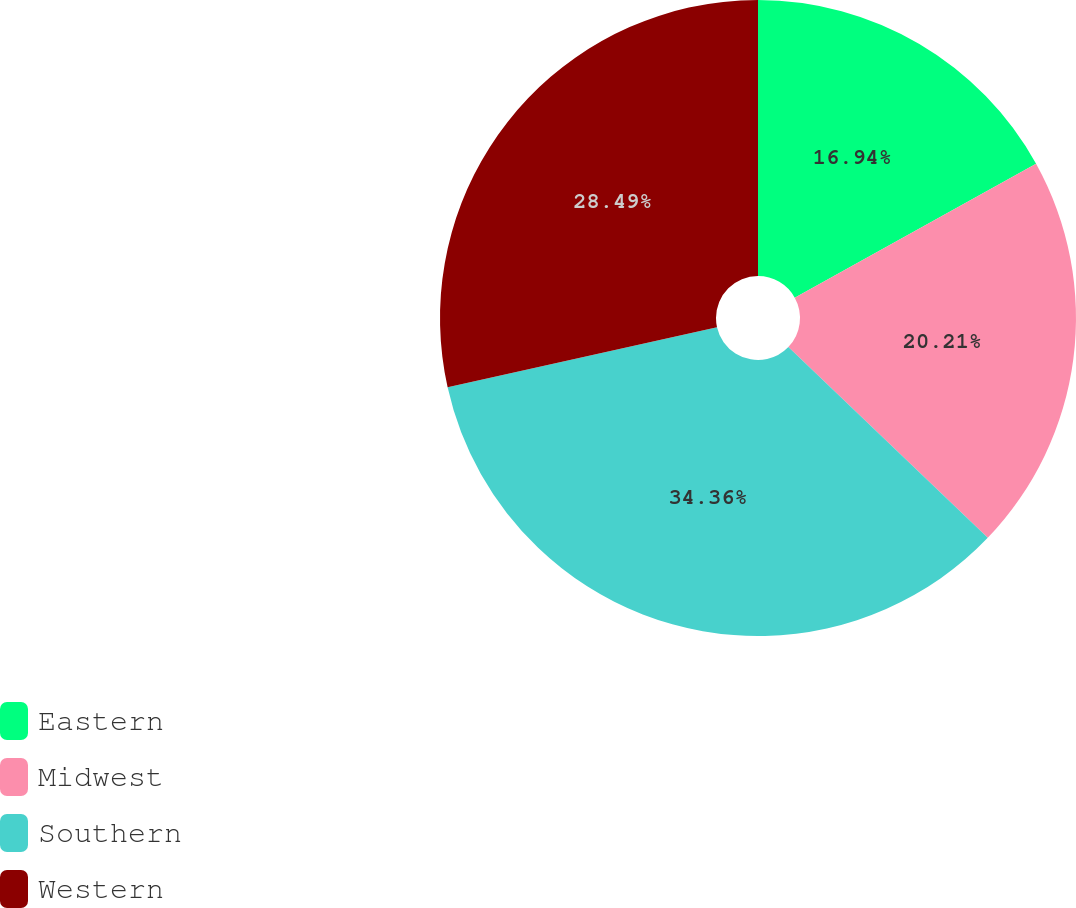Convert chart to OTSL. <chart><loc_0><loc_0><loc_500><loc_500><pie_chart><fcel>Eastern<fcel>Midwest<fcel>Southern<fcel>Western<nl><fcel>16.94%<fcel>20.21%<fcel>34.36%<fcel>28.49%<nl></chart> 